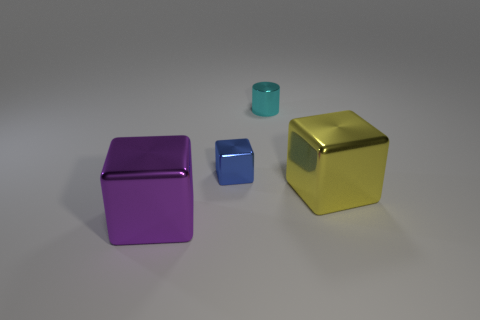The purple shiny object is what shape?
Your answer should be very brief. Cube. What number of small metallic blocks have the same color as the cylinder?
Give a very brief answer. 0. What color is the other tiny metallic object that is the same shape as the purple thing?
Give a very brief answer. Blue. How many big cubes are left of the big cube right of the tiny block?
Your answer should be very brief. 1. What number of cubes are yellow matte things or large purple shiny objects?
Your answer should be compact. 1. Are any large purple cylinders visible?
Provide a short and direct response. No. What size is the purple thing that is the same shape as the big yellow metal thing?
Give a very brief answer. Large. There is a tiny cyan object that is behind the large thing that is right of the small blue block; what shape is it?
Give a very brief answer. Cylinder. What number of cyan objects are either shiny things or tiny metal cubes?
Your answer should be very brief. 1. The small cylinder is what color?
Offer a terse response. Cyan. 